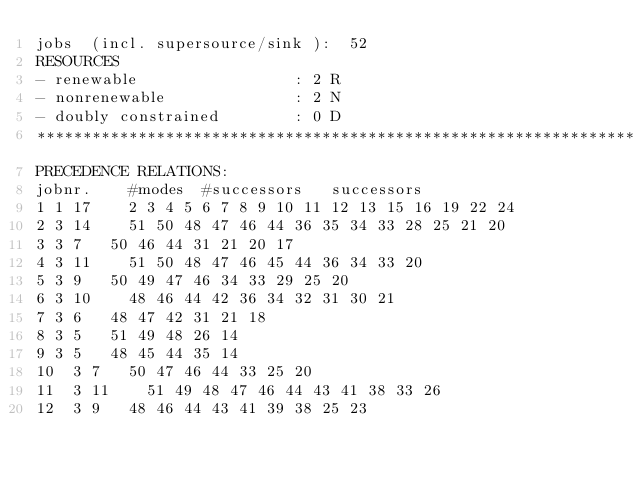Convert code to text. <code><loc_0><loc_0><loc_500><loc_500><_ObjectiveC_>jobs  (incl. supersource/sink ):	52
RESOURCES
- renewable                 : 2 R
- nonrenewable              : 2 N
- doubly constrained        : 0 D
************************************************************************
PRECEDENCE RELATIONS:
jobnr.    #modes  #successors   successors
1	1	17		2 3 4 5 6 7 8 9 10 11 12 13 15 16 19 22 24 
2	3	14		51 50 48 47 46 44 36 35 34 33 28 25 21 20 
3	3	7		50 46 44 31 21 20 17 
4	3	11		51 50 48 47 46 45 44 36 34 33 20 
5	3	9		50 49 47 46 34 33 29 25 20 
6	3	10		48 46 44 42 36 34 32 31 30 21 
7	3	6		48 47 42 31 21 18 
8	3	5		51 49 48 26 14 
9	3	5		48 45 44 35 14 
10	3	7		50 47 46 44 33 25 20 
11	3	11		51 49 48 47 46 44 43 41 38 33 26 
12	3	9		48 46 44 43 41 39 38 25 23 </code> 